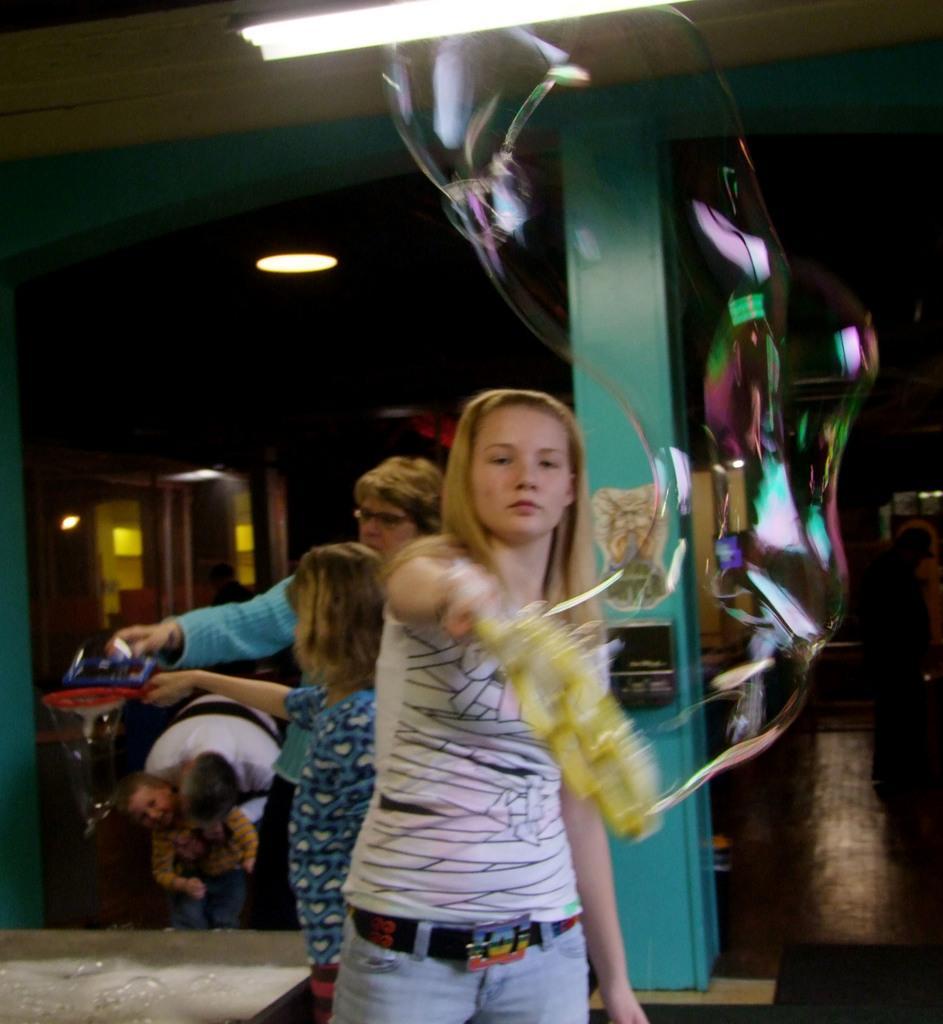In one or two sentences, can you explain what this image depicts? In this image we can see a person, bubble and other objects. In the background of the image there are persons, pillar, lights and other objects. At the top of the image there is a ceiling and light. 